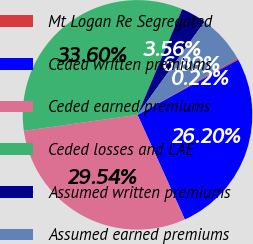<chart> <loc_0><loc_0><loc_500><loc_500><pie_chart><fcel>Mt Logan Re Segregated<fcel>Ceded written premiums<fcel>Ceded earned premiums<fcel>Ceded losses and LAE<fcel>Assumed written premiums<fcel>Assumed earned premiums<nl><fcel>0.22%<fcel>26.2%<fcel>29.54%<fcel>33.6%<fcel>3.56%<fcel>6.89%<nl></chart> 